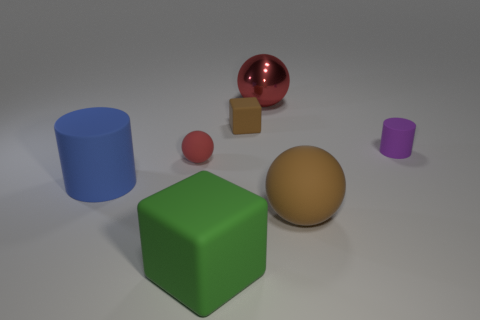Subtract all brown cylinders. How many red spheres are left? 2 Subtract all big brown balls. How many balls are left? 2 Add 1 tiny brown rubber objects. How many objects exist? 8 Subtract all spheres. How many objects are left? 4 Subtract all blue spheres. Subtract all brown cylinders. How many spheres are left? 3 Add 3 metallic things. How many metallic things are left? 4 Add 6 large gray metal cylinders. How many large gray metal cylinders exist? 6 Subtract 0 yellow blocks. How many objects are left? 7 Subtract all large red spheres. Subtract all brown matte blocks. How many objects are left? 5 